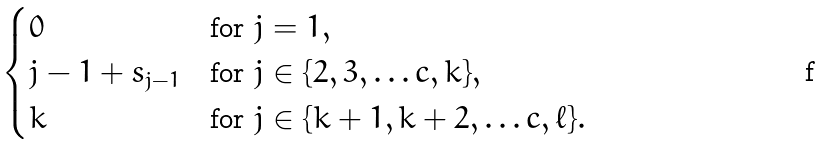Convert formula to latex. <formula><loc_0><loc_0><loc_500><loc_500>\begin{cases} 0 & \text {for } j = 1 , \\ j - 1 + s _ { j - 1 } & \text {for } j \in \{ 2 , 3 , \dots c , k \} , \\ k & \text {for } j \in \{ k + 1 , k + 2 , \dots c , \ell \} . \end{cases}</formula> 